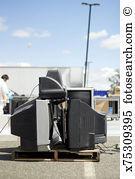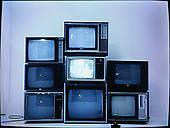The first image is the image on the left, the second image is the image on the right. Assess this claim about the two images: "Both images contain an equal number of monitors.". Correct or not? Answer yes or no. No. The first image is the image on the left, the second image is the image on the right. Given the left and right images, does the statement "tv's are stacked in a triangular shape" hold true? Answer yes or no. No. 